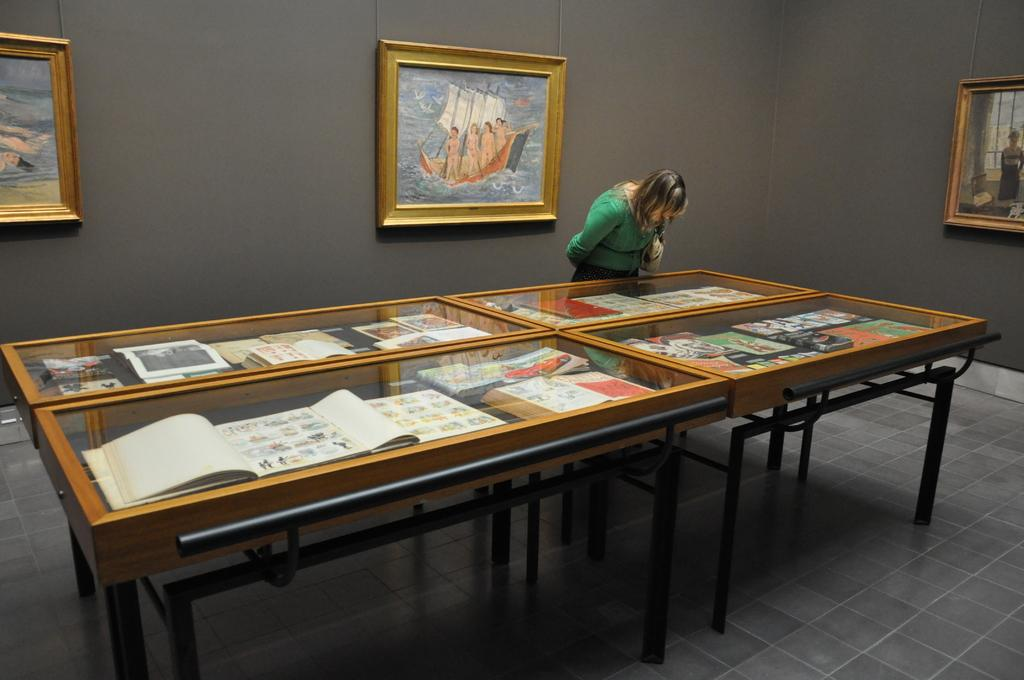Who is the main subject in the image? There is a woman in the image. What is the woman doing in the image? The woman is standing in front of a table. What can be seen on the wall in the image? There are frames attached to the wall in the image. What type of vase can be seen on the road in the image? There is no vase or road present in the image; it features a woman standing in front of a table in the image. 